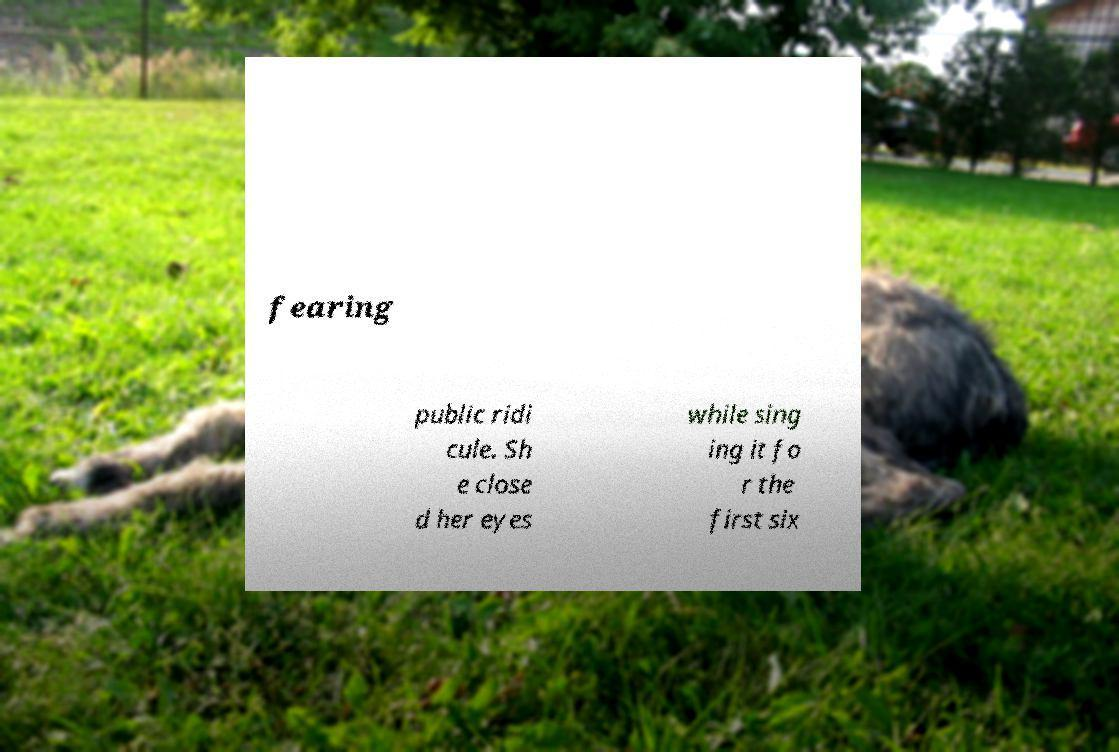Please read and relay the text visible in this image. What does it say? fearing public ridi cule. Sh e close d her eyes while sing ing it fo r the first six 